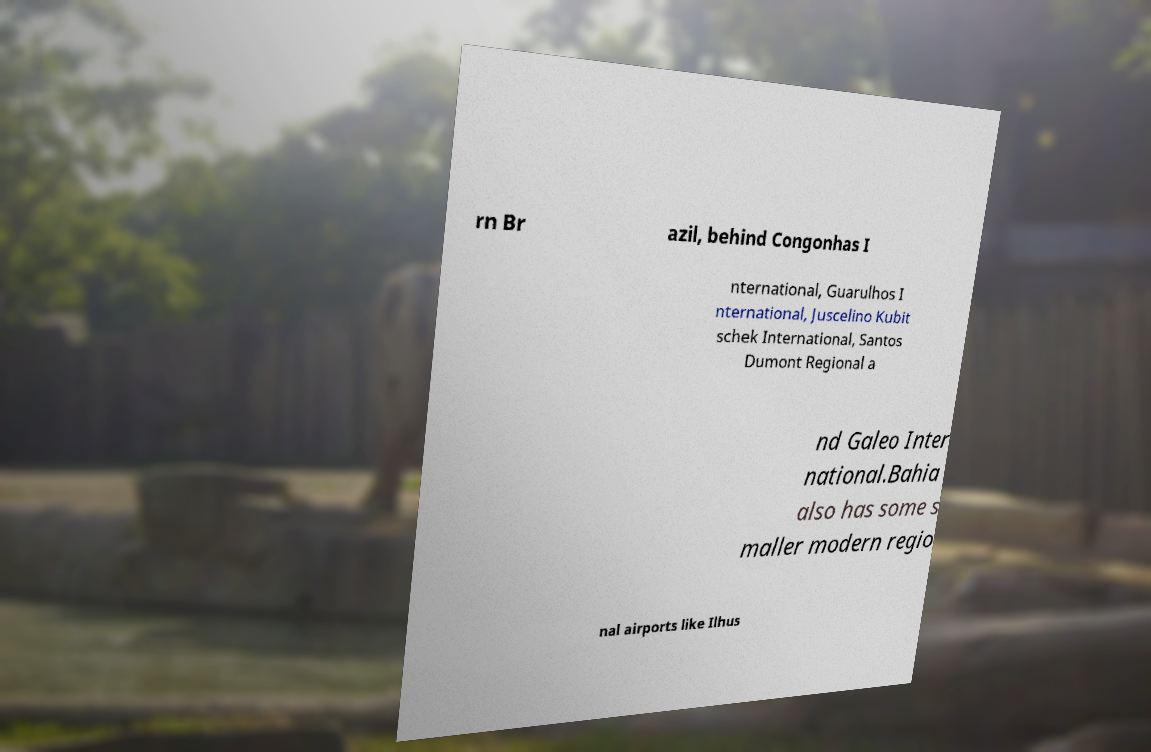Could you assist in decoding the text presented in this image and type it out clearly? rn Br azil, behind Congonhas I nternational, Guarulhos I nternational, Juscelino Kubit schek International, Santos Dumont Regional a nd Galeo Inter national.Bahia also has some s maller modern regio nal airports like Ilhus 